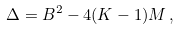Convert formula to latex. <formula><loc_0><loc_0><loc_500><loc_500>\Delta = B ^ { 2 } - 4 ( K - 1 ) M \, ,</formula> 